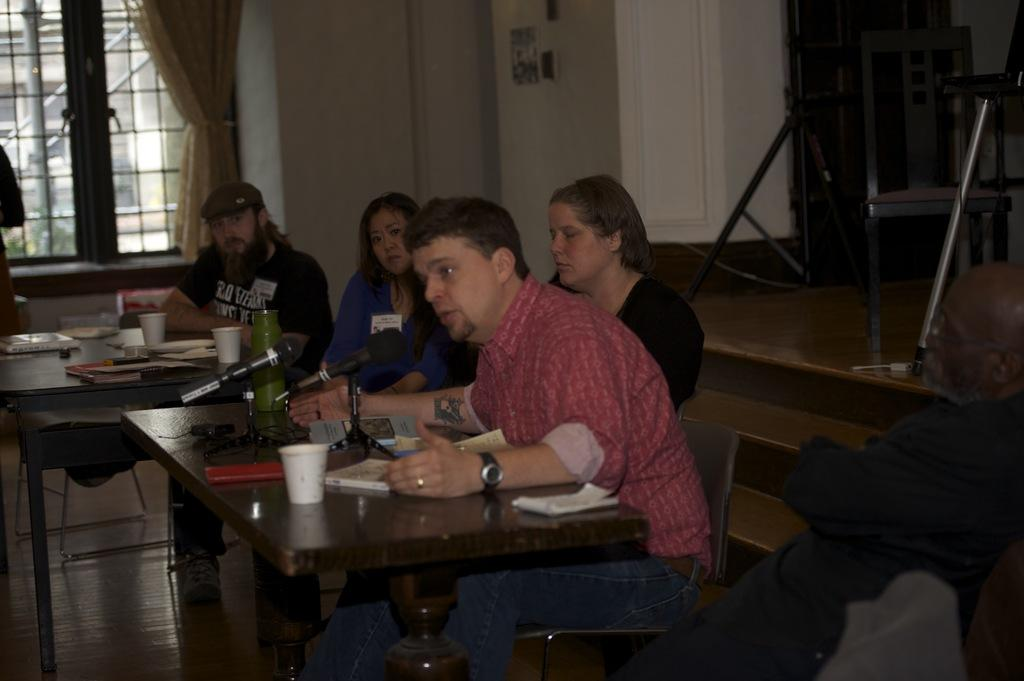What are the people in the image doing? People are sitting on chairs in the image. What objects can be seen on the table? There is a bottle, a cup, a book, and a microphone on the table. What is visible in the background of the image? There is a window, a curtain, and a wall in the background. How many boxes are present in the image? There are no boxes present in the image. What is the amount of money being discussed in the image? There is no mention of money or any financial transactions in the image. 